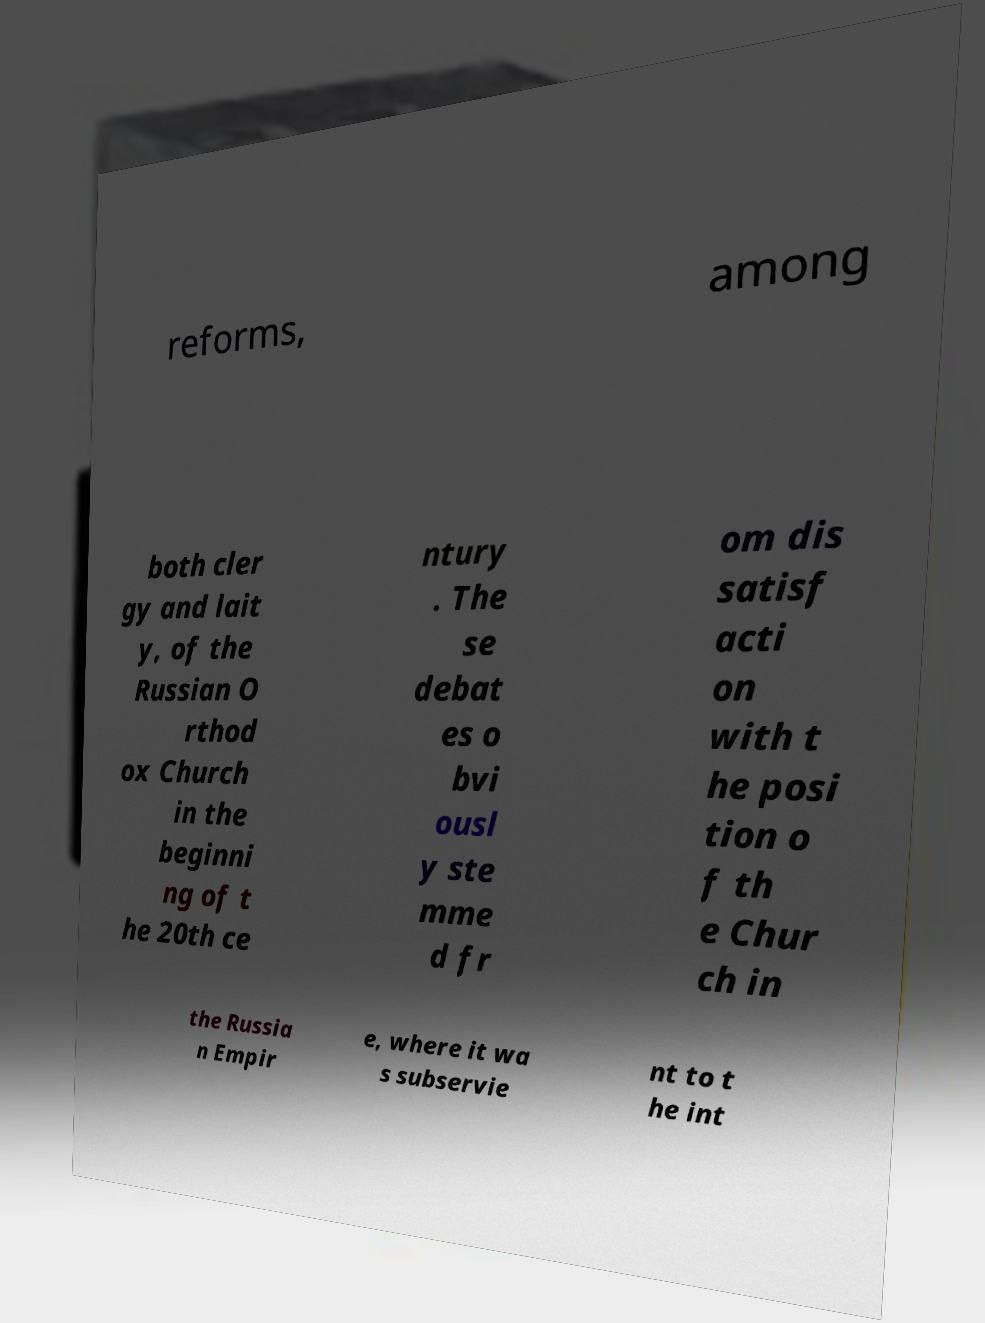Can you read and provide the text displayed in the image?This photo seems to have some interesting text. Can you extract and type it out for me? reforms, among both cler gy and lait y, of the Russian O rthod ox Church in the beginni ng of t he 20th ce ntury . The se debat es o bvi ousl y ste mme d fr om dis satisf acti on with t he posi tion o f th e Chur ch in the Russia n Empir e, where it wa s subservie nt to t he int 